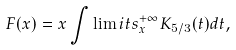<formula> <loc_0><loc_0><loc_500><loc_500>F ( x ) = x \int \lim i t s _ { x } ^ { + \infty } K _ { 5 / 3 } ( t ) d t ,</formula> 